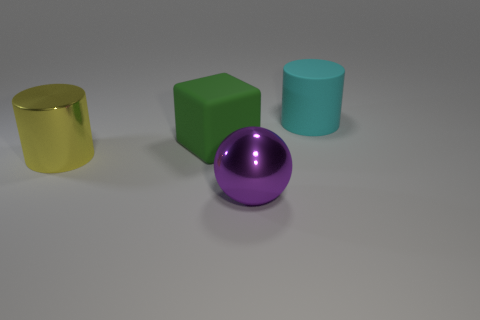Can you tell me the colors and materials of the objects from left to right? From left to right, there is a shiny yellow cylinder, a matte green cube, a shiny purple sphere, and a matte cyan cylinder. 